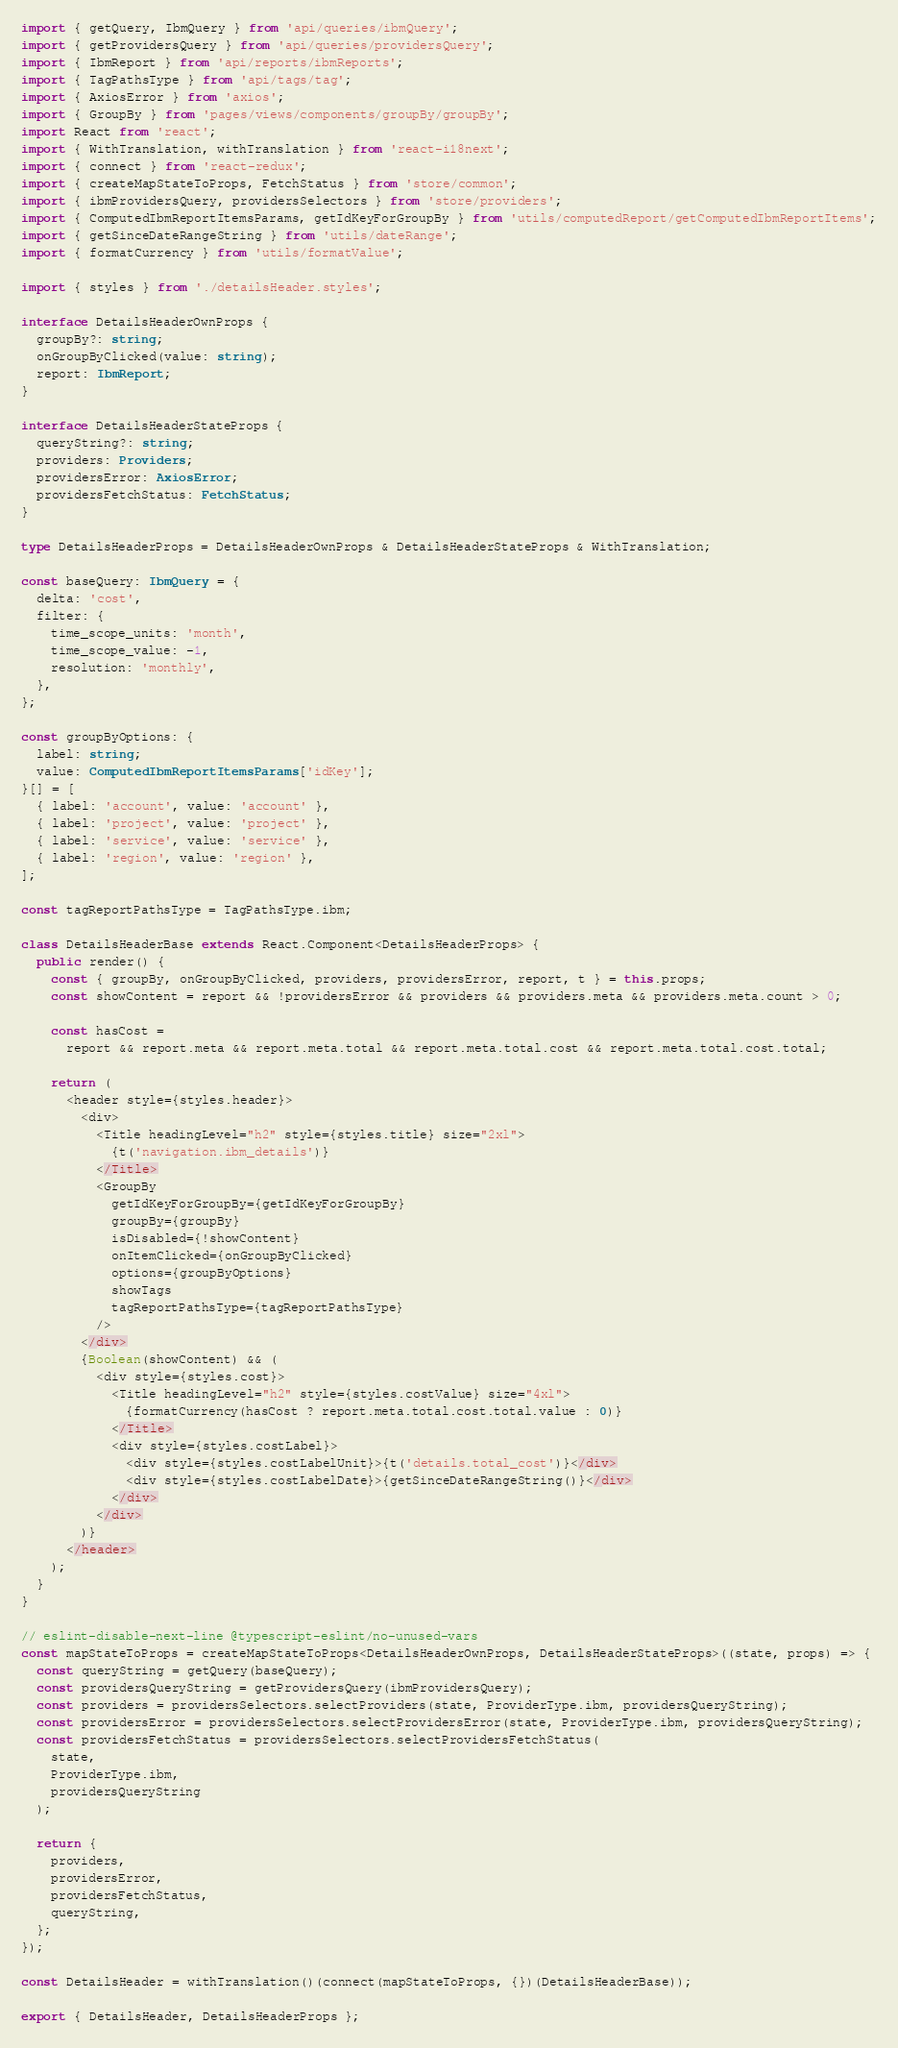<code> <loc_0><loc_0><loc_500><loc_500><_TypeScript_>import { getQuery, IbmQuery } from 'api/queries/ibmQuery';
import { getProvidersQuery } from 'api/queries/providersQuery';
import { IbmReport } from 'api/reports/ibmReports';
import { TagPathsType } from 'api/tags/tag';
import { AxiosError } from 'axios';
import { GroupBy } from 'pages/views/components/groupBy/groupBy';
import React from 'react';
import { WithTranslation, withTranslation } from 'react-i18next';
import { connect } from 'react-redux';
import { createMapStateToProps, FetchStatus } from 'store/common';
import { ibmProvidersQuery, providersSelectors } from 'store/providers';
import { ComputedIbmReportItemsParams, getIdKeyForGroupBy } from 'utils/computedReport/getComputedIbmReportItems';
import { getSinceDateRangeString } from 'utils/dateRange';
import { formatCurrency } from 'utils/formatValue';

import { styles } from './detailsHeader.styles';

interface DetailsHeaderOwnProps {
  groupBy?: string;
  onGroupByClicked(value: string);
  report: IbmReport;
}

interface DetailsHeaderStateProps {
  queryString?: string;
  providers: Providers;
  providersError: AxiosError;
  providersFetchStatus: FetchStatus;
}

type DetailsHeaderProps = DetailsHeaderOwnProps & DetailsHeaderStateProps & WithTranslation;

const baseQuery: IbmQuery = {
  delta: 'cost',
  filter: {
    time_scope_units: 'month',
    time_scope_value: -1,
    resolution: 'monthly',
  },
};

const groupByOptions: {
  label: string;
  value: ComputedIbmReportItemsParams['idKey'];
}[] = [
  { label: 'account', value: 'account' },
  { label: 'project', value: 'project' },
  { label: 'service', value: 'service' },
  { label: 'region', value: 'region' },
];

const tagReportPathsType = TagPathsType.ibm;

class DetailsHeaderBase extends React.Component<DetailsHeaderProps> {
  public render() {
    const { groupBy, onGroupByClicked, providers, providersError, report, t } = this.props;
    const showContent = report && !providersError && providers && providers.meta && providers.meta.count > 0;

    const hasCost =
      report && report.meta && report.meta.total && report.meta.total.cost && report.meta.total.cost.total;

    return (
      <header style={styles.header}>
        <div>
          <Title headingLevel="h2" style={styles.title} size="2xl">
            {t('navigation.ibm_details')}
          </Title>
          <GroupBy
            getIdKeyForGroupBy={getIdKeyForGroupBy}
            groupBy={groupBy}
            isDisabled={!showContent}
            onItemClicked={onGroupByClicked}
            options={groupByOptions}
            showTags
            tagReportPathsType={tagReportPathsType}
          />
        </div>
        {Boolean(showContent) && (
          <div style={styles.cost}>
            <Title headingLevel="h2" style={styles.costValue} size="4xl">
              {formatCurrency(hasCost ? report.meta.total.cost.total.value : 0)}
            </Title>
            <div style={styles.costLabel}>
              <div style={styles.costLabelUnit}>{t('details.total_cost')}</div>
              <div style={styles.costLabelDate}>{getSinceDateRangeString()}</div>
            </div>
          </div>
        )}
      </header>
    );
  }
}

// eslint-disable-next-line @typescript-eslint/no-unused-vars
const mapStateToProps = createMapStateToProps<DetailsHeaderOwnProps, DetailsHeaderStateProps>((state, props) => {
  const queryString = getQuery(baseQuery);
  const providersQueryString = getProvidersQuery(ibmProvidersQuery);
  const providers = providersSelectors.selectProviders(state, ProviderType.ibm, providersQueryString);
  const providersError = providersSelectors.selectProvidersError(state, ProviderType.ibm, providersQueryString);
  const providersFetchStatus = providersSelectors.selectProvidersFetchStatus(
    state,
    ProviderType.ibm,
    providersQueryString
  );

  return {
    providers,
    providersError,
    providersFetchStatus,
    queryString,
  };
});

const DetailsHeader = withTranslation()(connect(mapStateToProps, {})(DetailsHeaderBase));

export { DetailsHeader, DetailsHeaderProps };
</code> 